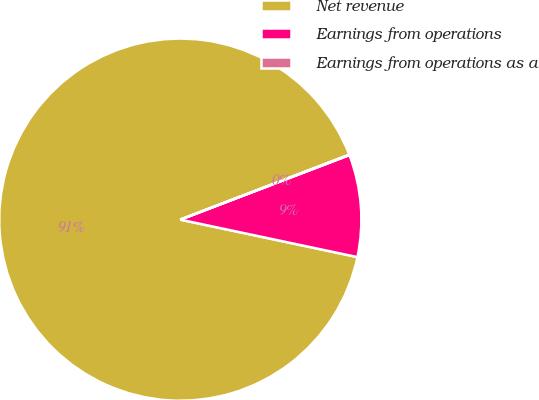Convert chart. <chart><loc_0><loc_0><loc_500><loc_500><pie_chart><fcel>Net revenue<fcel>Earnings from operations<fcel>Earnings from operations as a<nl><fcel>90.83%<fcel>9.12%<fcel>0.04%<nl></chart> 